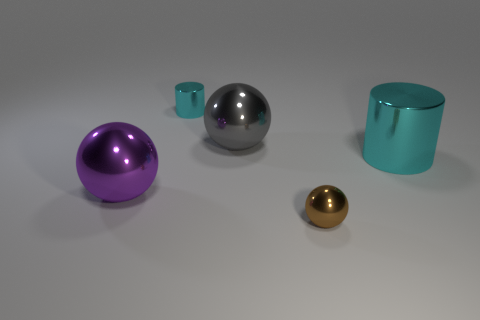What number of cylinders are cyan matte things or big purple things?
Make the answer very short. 0. Is there a tiny yellow metal cylinder?
Provide a short and direct response. No. The gray metal thing that is the same shape as the brown object is what size?
Ensure brevity in your answer.  Large. There is a cyan shiny object that is right of the large ball that is behind the big purple sphere; what is its shape?
Provide a short and direct response. Cylinder. What number of cyan objects are either small things or big metal cylinders?
Provide a succinct answer. 2. The big metallic cylinder is what color?
Give a very brief answer. Cyan. Does the gray metal object have the same size as the brown shiny thing?
Offer a terse response. No. Does the big gray ball have the same material as the cylinder behind the large gray metal thing?
Offer a terse response. Yes. Do the big metal thing that is on the right side of the gray metallic ball and the small metallic cylinder have the same color?
Your response must be concise. Yes. How many shiny cylinders are in front of the gray thing and behind the large cylinder?
Give a very brief answer. 0. 